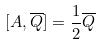<formula> <loc_0><loc_0><loc_500><loc_500>[ A , \overline { Q } ] = \frac { 1 } { 2 } \overline { Q }</formula> 